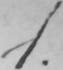Please provide the text content of this handwritten line. 1 . 